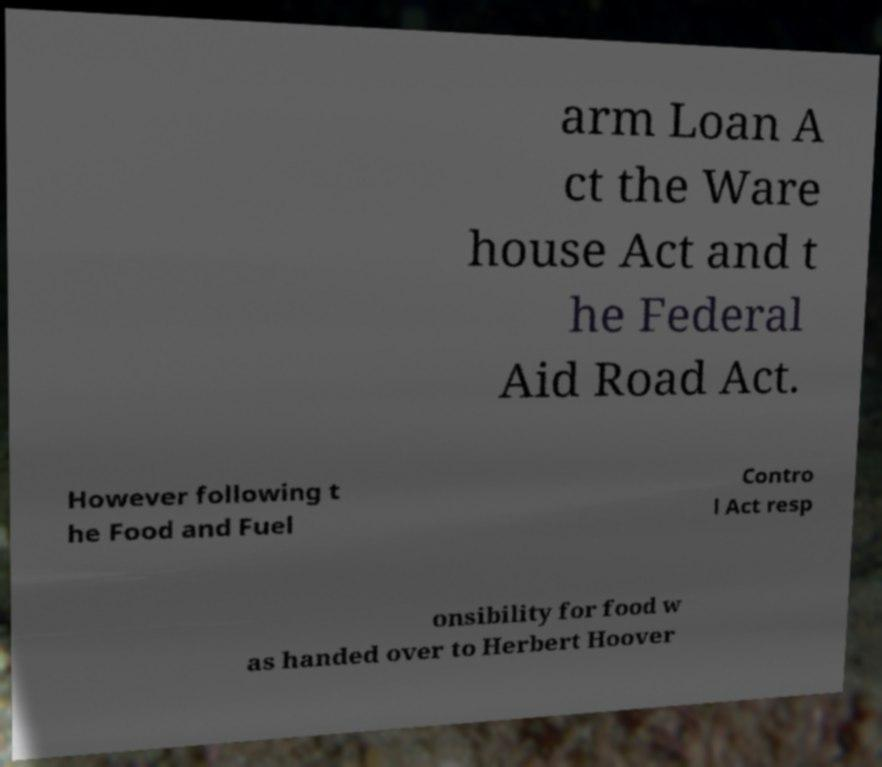Please identify and transcribe the text found in this image. arm Loan A ct the Ware house Act and t he Federal Aid Road Act. However following t he Food and Fuel Contro l Act resp onsibility for food w as handed over to Herbert Hoover 